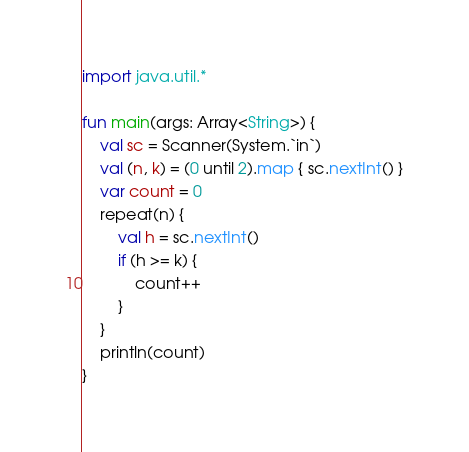Convert code to text. <code><loc_0><loc_0><loc_500><loc_500><_Kotlin_>import java.util.*

fun main(args: Array<String>) {
    val sc = Scanner(System.`in`)
    val (n, k) = (0 until 2).map { sc.nextInt() }
    var count = 0
    repeat(n) {
        val h = sc.nextInt()
        if (h >= k) {
            count++
        }
    }
    println(count)
}</code> 